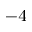<formula> <loc_0><loc_0><loc_500><loc_500>^ { - 4 }</formula> 